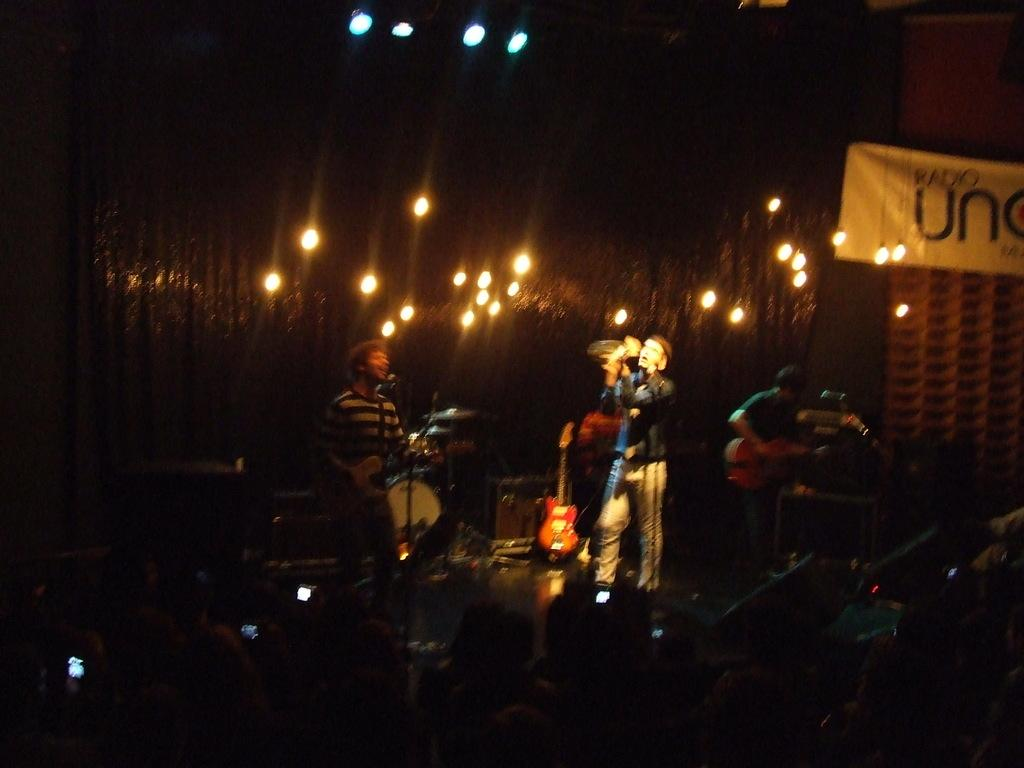What are the boys doing on the stage in the image? The boys are performing music on the stage. What can be seen in the center of the image? There are lights in the center of the image. What musical instruments are present on the stage? The stage contains a drum set and a guitar. What equipment is used for amplifying the boys' voices on the stage? The stage contains microphones (mics). What type of cloth is being used for digestion by the boys on the stage? There is no cloth or digestion-related activity present in the image; the boys are performing music on the stage. 